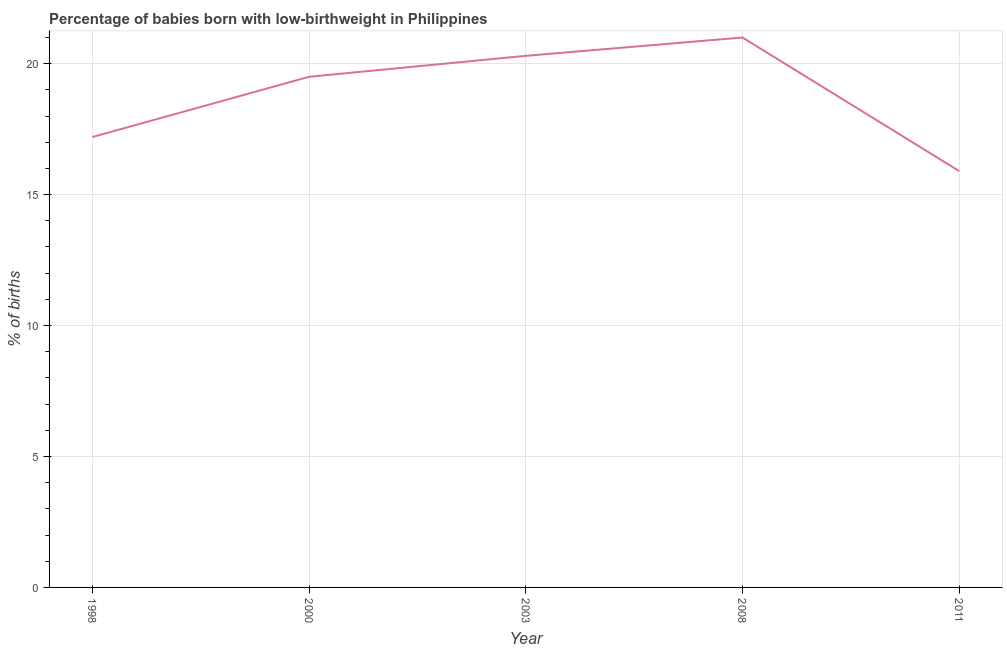What is the percentage of babies who were born with low-birthweight in 2011?
Provide a succinct answer. 15.9. Across all years, what is the maximum percentage of babies who were born with low-birthweight?
Your answer should be compact. 21. Across all years, what is the minimum percentage of babies who were born with low-birthweight?
Make the answer very short. 15.9. In which year was the percentage of babies who were born with low-birthweight maximum?
Keep it short and to the point. 2008. In which year was the percentage of babies who were born with low-birthweight minimum?
Keep it short and to the point. 2011. What is the sum of the percentage of babies who were born with low-birthweight?
Your response must be concise. 93.9. What is the average percentage of babies who were born with low-birthweight per year?
Provide a short and direct response. 18.78. What is the ratio of the percentage of babies who were born with low-birthweight in 1998 to that in 2000?
Offer a terse response. 0.88. What is the difference between the highest and the second highest percentage of babies who were born with low-birthweight?
Your answer should be very brief. 0.7. Is the sum of the percentage of babies who were born with low-birthweight in 1998 and 2008 greater than the maximum percentage of babies who were born with low-birthweight across all years?
Keep it short and to the point. Yes. How many lines are there?
Your answer should be very brief. 1. How many years are there in the graph?
Provide a short and direct response. 5. What is the difference between two consecutive major ticks on the Y-axis?
Your response must be concise. 5. Are the values on the major ticks of Y-axis written in scientific E-notation?
Your response must be concise. No. Does the graph contain any zero values?
Provide a succinct answer. No. What is the title of the graph?
Ensure brevity in your answer.  Percentage of babies born with low-birthweight in Philippines. What is the label or title of the Y-axis?
Your response must be concise. % of births. What is the % of births in 2003?
Offer a terse response. 20.3. What is the difference between the % of births in 1998 and 2008?
Your answer should be compact. -3.8. What is the difference between the % of births in 2000 and 2003?
Give a very brief answer. -0.8. What is the difference between the % of births in 2000 and 2008?
Keep it short and to the point. -1.5. What is the difference between the % of births in 2000 and 2011?
Ensure brevity in your answer.  3.6. What is the difference between the % of births in 2003 and 2008?
Provide a succinct answer. -0.7. What is the ratio of the % of births in 1998 to that in 2000?
Offer a very short reply. 0.88. What is the ratio of the % of births in 1998 to that in 2003?
Keep it short and to the point. 0.85. What is the ratio of the % of births in 1998 to that in 2008?
Your response must be concise. 0.82. What is the ratio of the % of births in 1998 to that in 2011?
Make the answer very short. 1.08. What is the ratio of the % of births in 2000 to that in 2003?
Provide a short and direct response. 0.96. What is the ratio of the % of births in 2000 to that in 2008?
Offer a very short reply. 0.93. What is the ratio of the % of births in 2000 to that in 2011?
Ensure brevity in your answer.  1.23. What is the ratio of the % of births in 2003 to that in 2008?
Provide a succinct answer. 0.97. What is the ratio of the % of births in 2003 to that in 2011?
Your answer should be compact. 1.28. What is the ratio of the % of births in 2008 to that in 2011?
Ensure brevity in your answer.  1.32. 